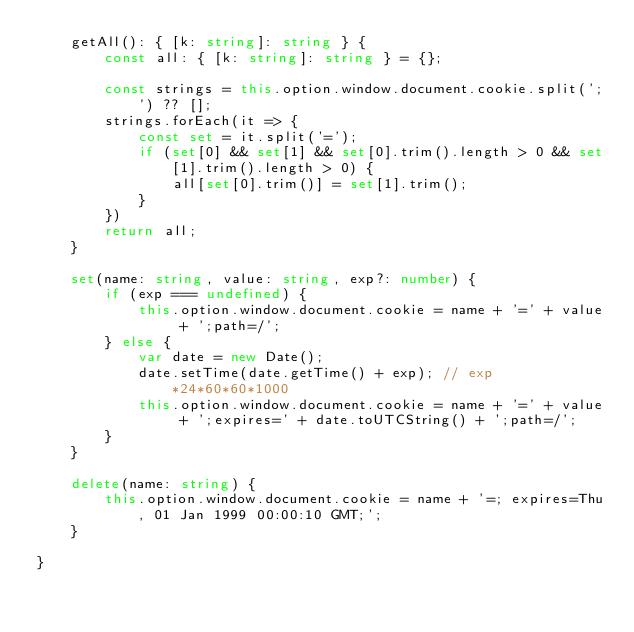Convert code to text. <code><loc_0><loc_0><loc_500><loc_500><_TypeScript_>    getAll(): { [k: string]: string } {
        const all: { [k: string]: string } = {};

        const strings = this.option.window.document.cookie.split(';') ?? [];
        strings.forEach(it => {
            const set = it.split('=');
            if (set[0] && set[1] && set[0].trim().length > 0 && set[1].trim().length > 0) {
                all[set[0].trim()] = set[1].trim();
            }
        })
        return all;
    }

    set(name: string, value: string, exp?: number) {
        if (exp === undefined) {
            this.option.window.document.cookie = name + '=' + value + ';path=/';
        } else {
            var date = new Date();
            date.setTime(date.getTime() + exp); // exp*24*60*60*1000
            this.option.window.document.cookie = name + '=' + value + ';expires=' + date.toUTCString() + ';path=/';
        }
    }

    delete(name: string) {
        this.option.window.document.cookie = name + '=; expires=Thu, 01 Jan 1999 00:00:10 GMT;';
    }

}
</code> 